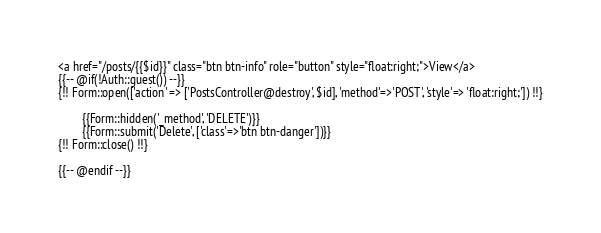<code> <loc_0><loc_0><loc_500><loc_500><_PHP_>
<a href="/posts/{{$id}}" class="btn btn-info" role="button" style="float:right;">View</a>
{{-- @if(!Auth::guest()) --}}
{!! Form::open(['action' => ['PostsController@destroy', $id], 'method'=>'POST', 'style'=> 'float:right;']) !!}

        {{Form::hidden('_method', 'DELETE')}}
        {{Form::submit('Delete', ['class'=>'btn btn-danger'])}}
{!! Form::close() !!}

{{-- @endif --}}
</code> 